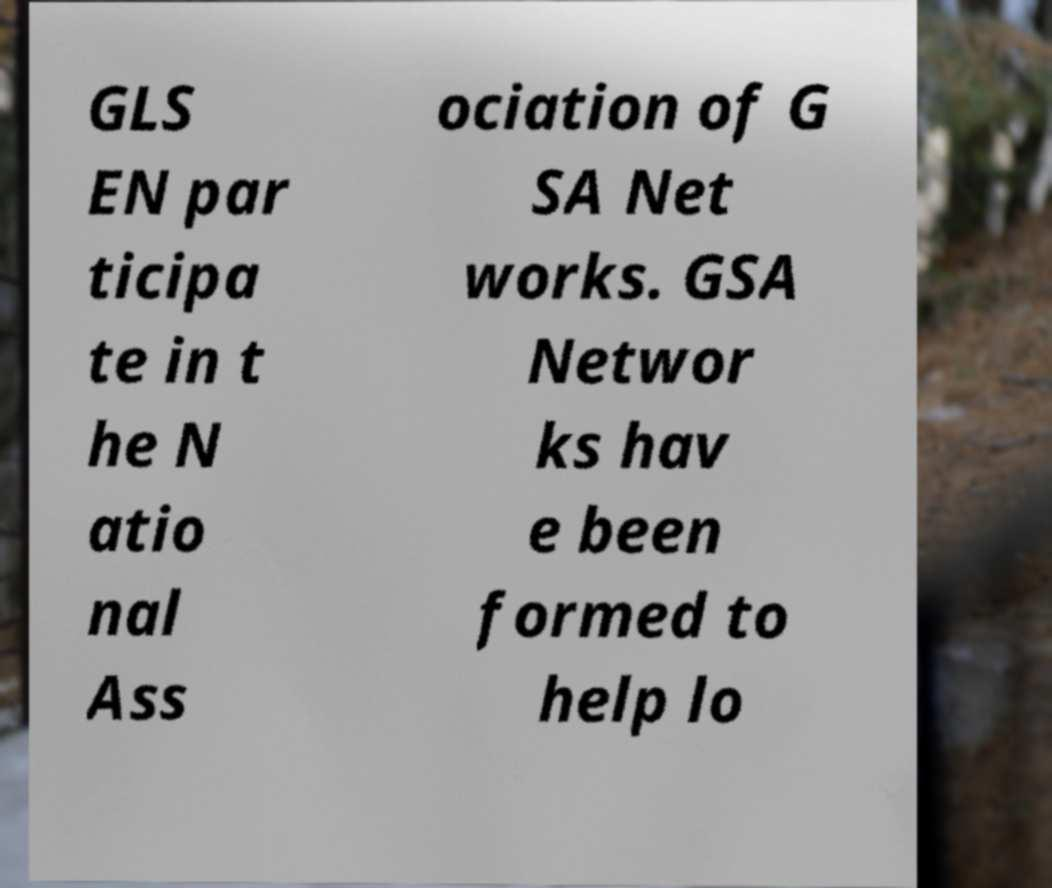Can you read and provide the text displayed in the image?This photo seems to have some interesting text. Can you extract and type it out for me? GLS EN par ticipa te in t he N atio nal Ass ociation of G SA Net works. GSA Networ ks hav e been formed to help lo 